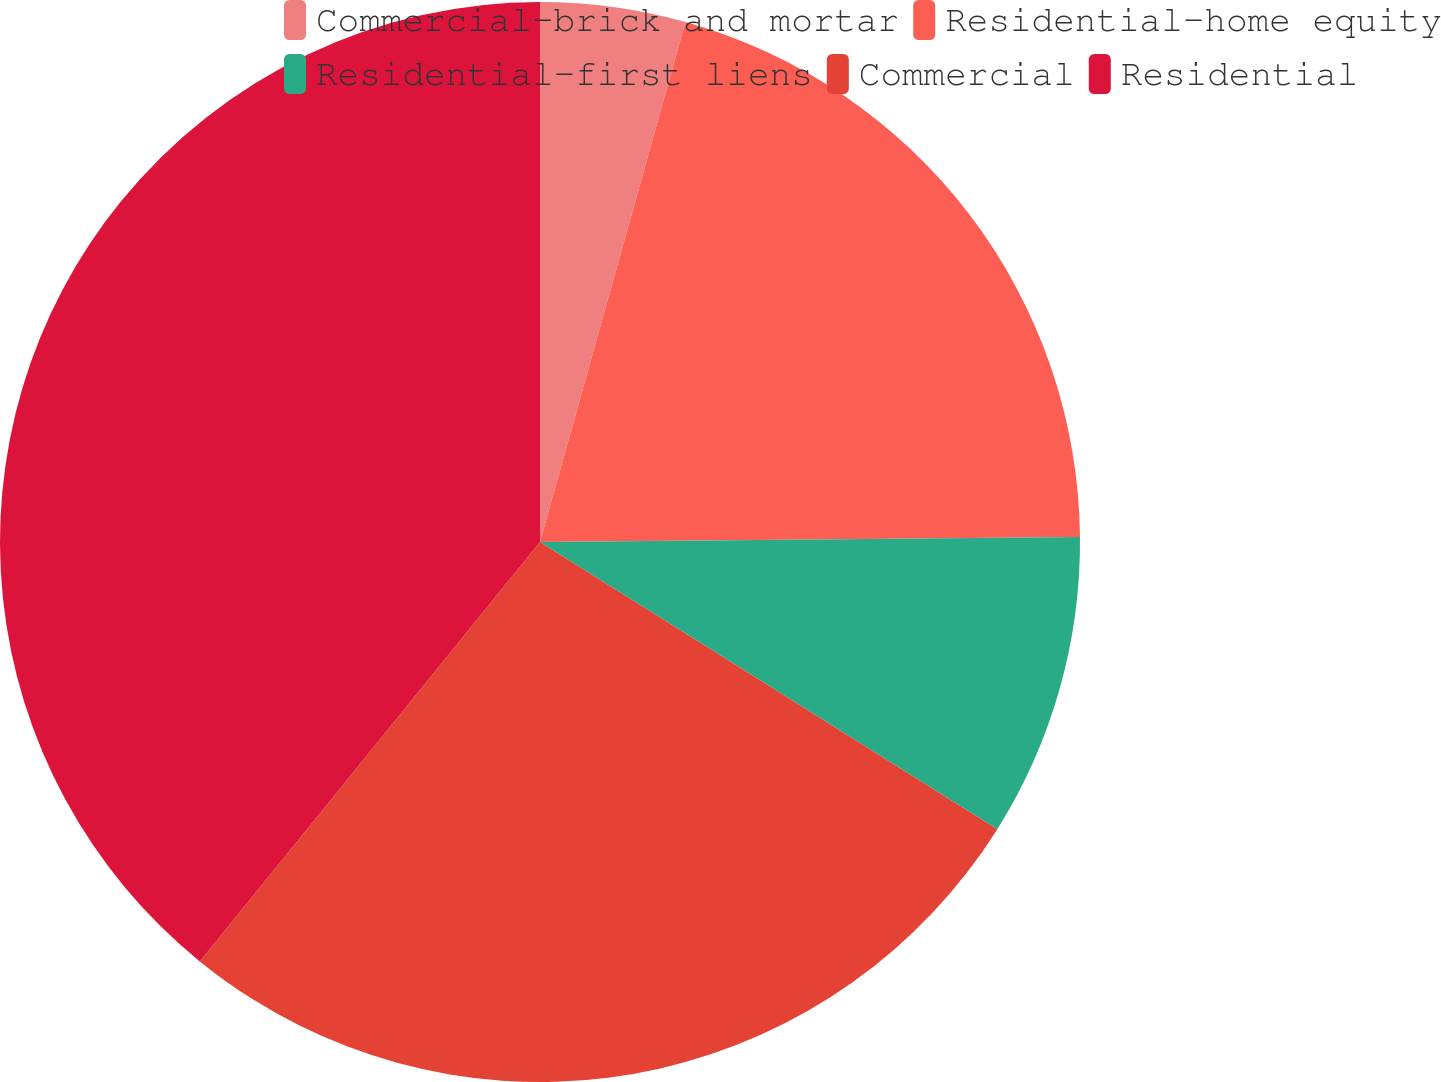Convert chart. <chart><loc_0><loc_0><loc_500><loc_500><pie_chart><fcel>Commercial-brick and mortar<fcel>Residential-home equity<fcel>Residential-first liens<fcel>Commercial<fcel>Residential<nl><fcel>4.34%<fcel>20.51%<fcel>9.07%<fcel>26.92%<fcel>39.15%<nl></chart> 